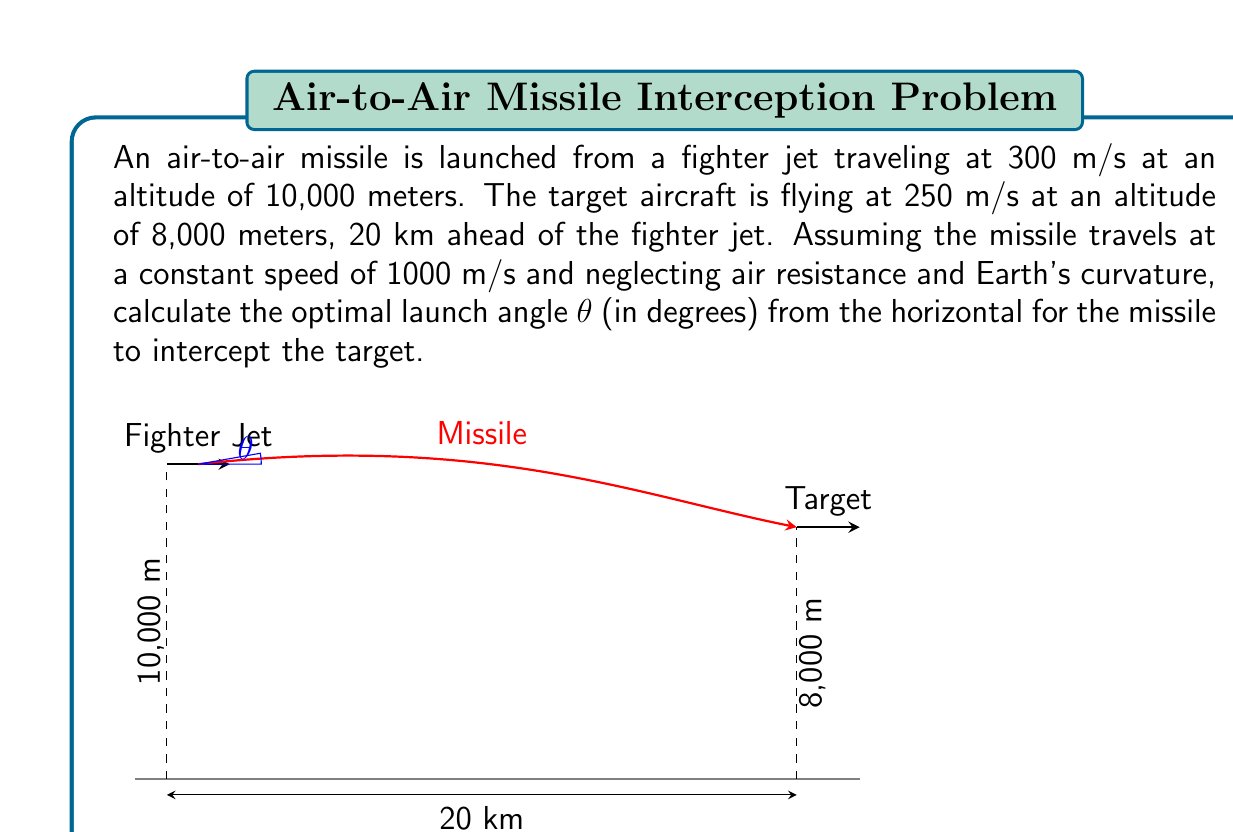Show me your answer to this math problem. To solve this problem, we'll use the principles of projectile motion and relative motion. Let's break it down step-by-step:

1) First, we need to calculate the time it takes for the missile to reach the target. Let's call this time $t$.

2) The relative velocity between the missile and the fighter jet in the horizontal direction is:
   $v_{x,relative} = 1000 \cos θ - 300$ m/s

3) The horizontal distance covered in time $t$ is:
   $20000 = (1000 \cos θ - 300)t$

4) In the vertical direction, we have:
   $-2000 = 1000 \sin θ \cdot t$

5) From (4), we can express $t$:
   $t = \frac{-2000}{1000 \sin θ} = \frac{-2}{\sin θ}$

6) Substituting this into (3):
   $20000 = (1000 \cos θ - 300) \cdot \frac{-2}{\sin θ}$

7) Simplifying:
   $-10000 \sin θ = (-2000 \cos θ + 600)$

8) Rearranging:
   $10000 \sin θ + 2000 \cos θ = 600$

9) Dividing both sides by 2000:
   $5 \sin θ + \cos θ = 0.3$

10) This is in the form of $a \sin θ + b \cos θ = c$, which has the solution:
    $θ = \arcsin(\frac{c}{\sqrt{a^2 + b^2}}) - \arctan(\frac{b}{a})$

11) Substituting our values:
    $θ = \arcsin(\frac{0.3}{\sqrt{5^2 + 1^2}}) - \arctan(\frac{1}{5})$

12) Calculating:
    $θ ≈ 3.43°$

Therefore, the optimal launch angle is approximately 3.43 degrees from the horizontal.
Answer: $3.43°$ 